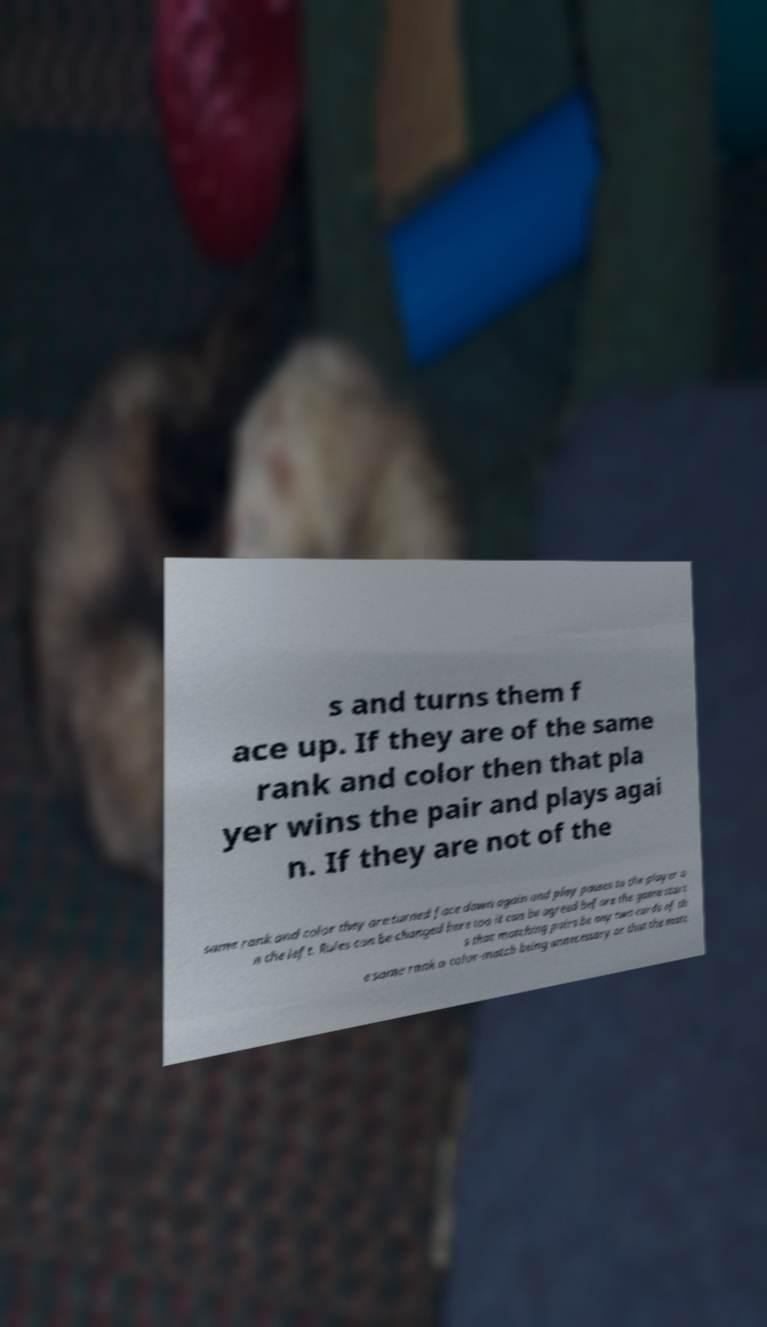Can you accurately transcribe the text from the provided image for me? s and turns them f ace up. If they are of the same rank and color then that pla yer wins the pair and plays agai n. If they are not of the same rank and color they are turned face down again and play passes to the player o n the left. Rules can be changed here too it can be agreed before the game start s that matching pairs be any two cards of th e same rank a color-match being unnecessary or that the matc 